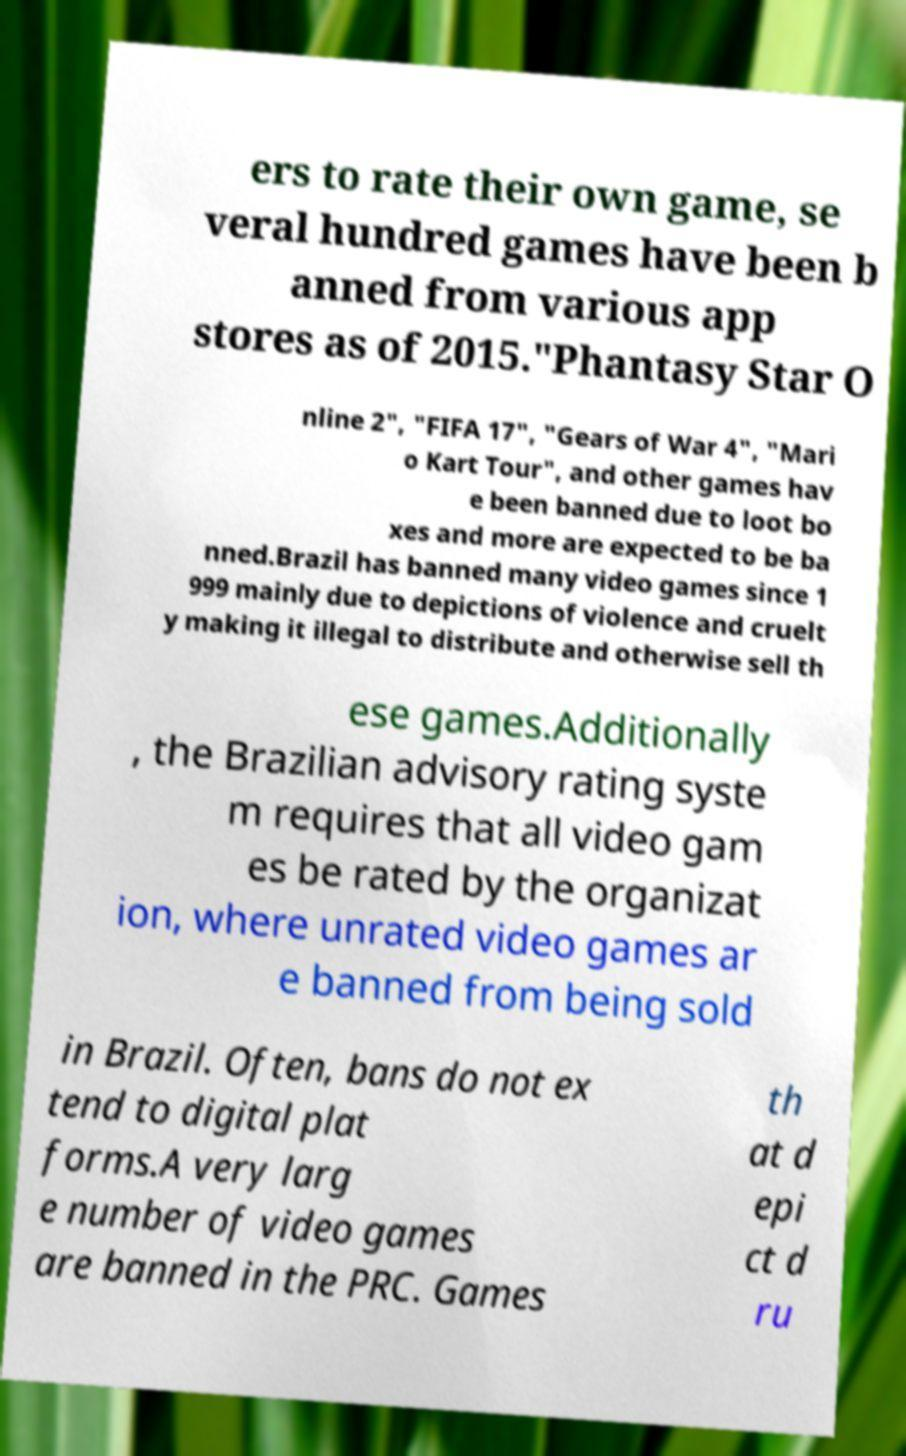For documentation purposes, I need the text within this image transcribed. Could you provide that? ers to rate their own game, se veral hundred games have been b anned from various app stores as of 2015."Phantasy Star O nline 2", "FIFA 17", "Gears of War 4", "Mari o Kart Tour", and other games hav e been banned due to loot bo xes and more are expected to be ba nned.Brazil has banned many video games since 1 999 mainly due to depictions of violence and cruelt y making it illegal to distribute and otherwise sell th ese games.Additionally , the Brazilian advisory rating syste m requires that all video gam es be rated by the organizat ion, where unrated video games ar e banned from being sold in Brazil. Often, bans do not ex tend to digital plat forms.A very larg e number of video games are banned in the PRC. Games th at d epi ct d ru 